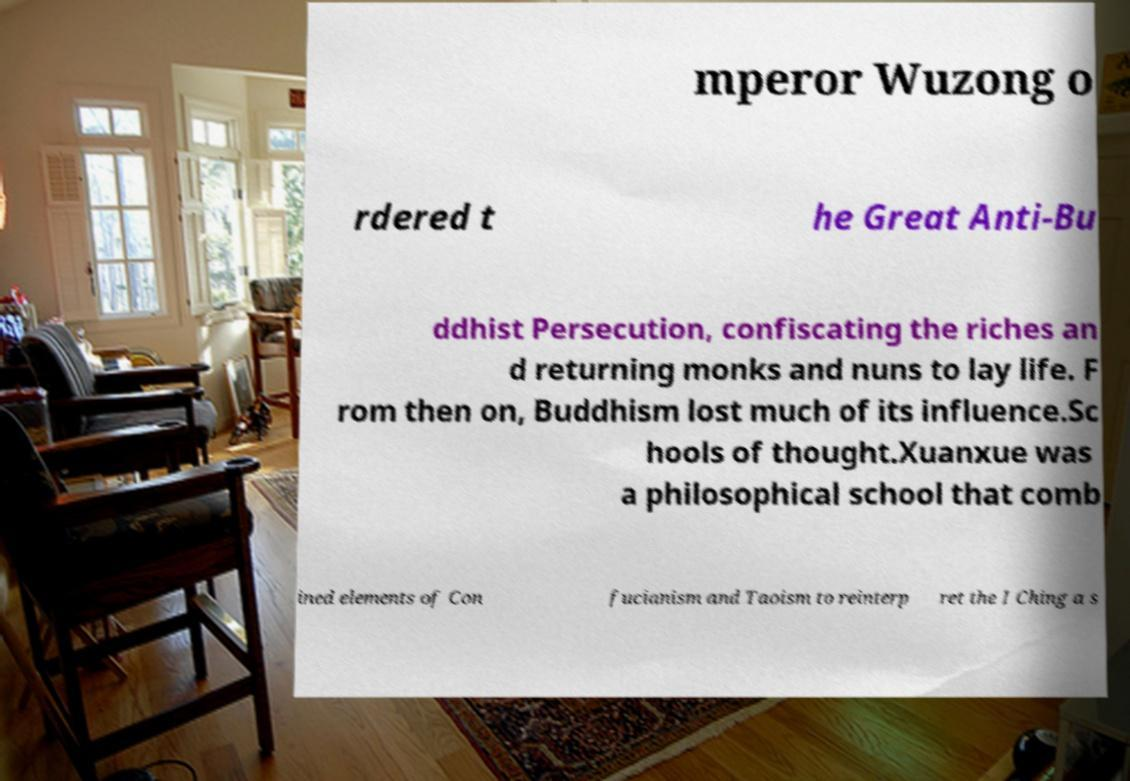Can you read and provide the text displayed in the image?This photo seems to have some interesting text. Can you extract and type it out for me? mperor Wuzong o rdered t he Great Anti-Bu ddhist Persecution, confiscating the riches an d returning monks and nuns to lay life. F rom then on, Buddhism lost much of its influence.Sc hools of thought.Xuanxue was a philosophical school that comb ined elements of Con fucianism and Taoism to reinterp ret the I Ching a s 